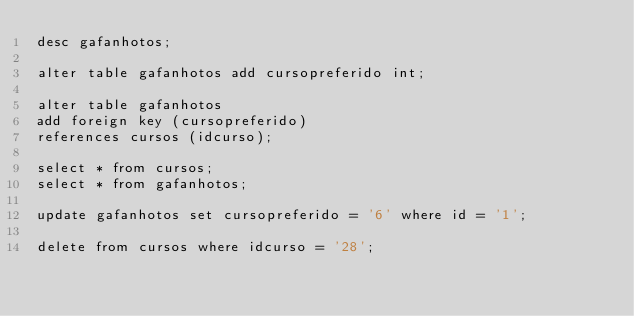Convert code to text. <code><loc_0><loc_0><loc_500><loc_500><_SQL_>desc gafanhotos;

alter table gafanhotos add cursopreferido int;

alter table gafanhotos
add foreign key (cursopreferido)
references cursos (idcurso);

select * from cursos;
select * from gafanhotos;

update gafanhotos set cursopreferido = '6' where id = '1';

delete from cursos where idcurso = '28';



</code> 